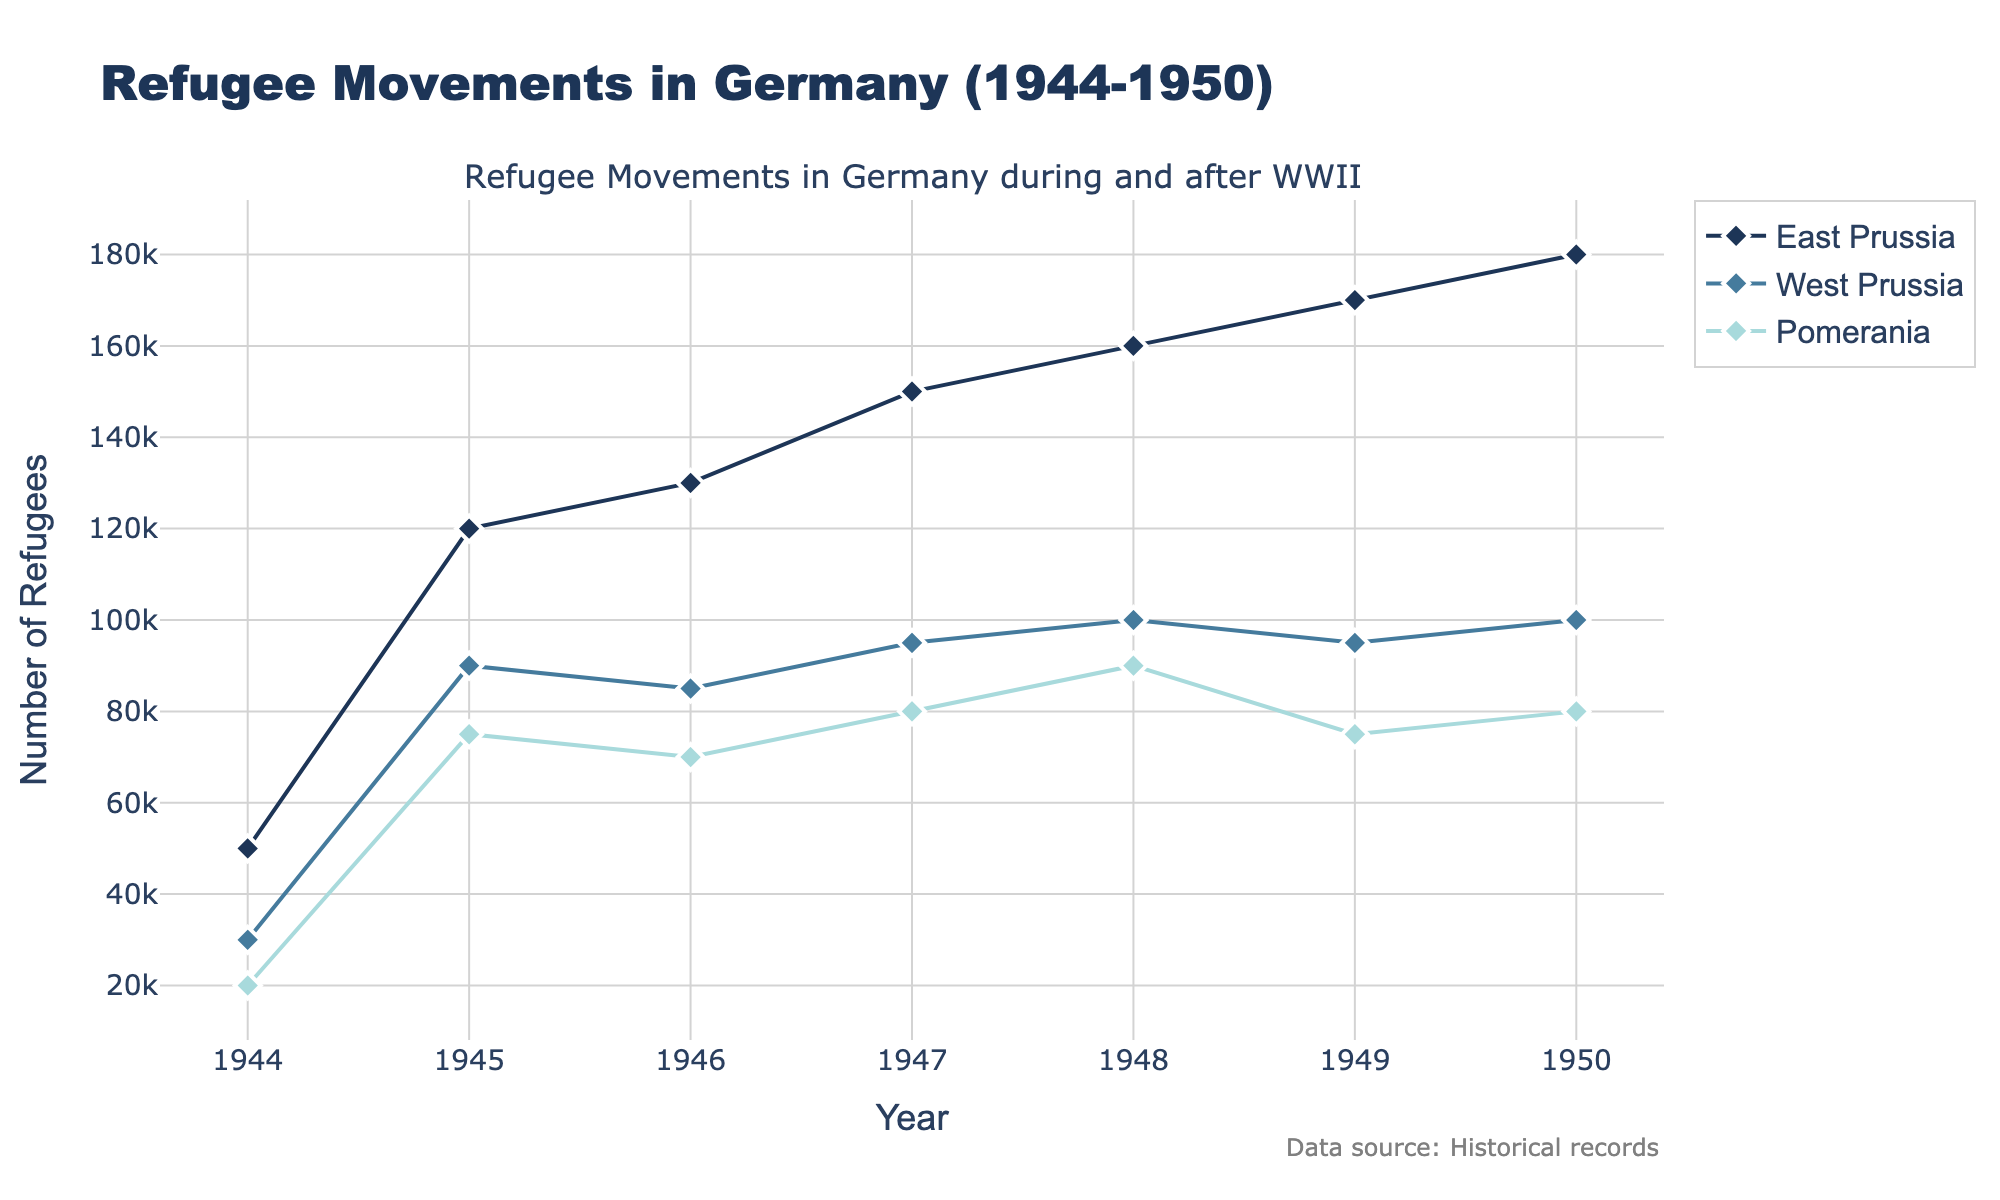When did East Prussia see the highest number of refugees? By examining the line for East Prussia, we can observe that it peaks in 1950.
Answer: 1950 Which region had the least number of refugees in 1944? By comparing the data points for 1944, Pomerania had the smallest number of refugees with 20,000.
Answer: Pomerania What trend is observed in the number of refugees in West Prussia between 1944 and 1950? The number of refugees in West Prussia shows a generally increasing trend, starting from 30,000 in 1944 and reaching 100,000 in 1950.
Answer: Increasing Which year did Pomerania have the lowest number of refugees? Observing the plotted data points for Pomerania, the lowest number, 20,000, is in 1944.
Answer: 1944 Between 1945 and 1947, did the number of refugees increase or decrease in East Prussia? By evaluating the points for 1945, 1946, and 1947, we can see that the number of refugees increased from 120,000 to 150,000.
Answer: Increase How many regions had an increase in the number of refugees from 1948 to 1949? By comparing the figures for 1948 and 1949 for all regions, East Prussia increased from 160,000 to 170,000 and Pomerania decreased from 90,000 to 75,000, while West Prussia decreased from 100,000 to 95,000. So only East Prussia increased.
Answer: One What is the average number of refugees in Pomerania over the period 1944-1950? Pomerania had the following numbers of refugees: 20,000, 75,000, 70,000, 80,000, 90,000, 75,000, 80,000. Summing these gives 490,000, and dividing by 7 years gives an average of 70,000.
Answer: 70,000 Comparing East Prussia and West Prussia, which had more refugees in 1946? Examining the figures for 1946, East Prussia had 130,000 and West Prussia had 85,000. East Prussia had more refugees.
Answer: East Prussia Which region showed the most volatile refugee movements between 1944 and 1950? Evaluating the fluctuations in the number of refugees over the years, East Prussia showed the most noticeable increases, indicating greater volatility.
Answer: East Prussia What is the sum of the refugees in all regions for the year 1950? Adding the respective numbers for all regions in 1950: East Prussia (180,000) + West Prussia (100,000) + Pomerania (80,000) = 360,000.
Answer: 360,000 